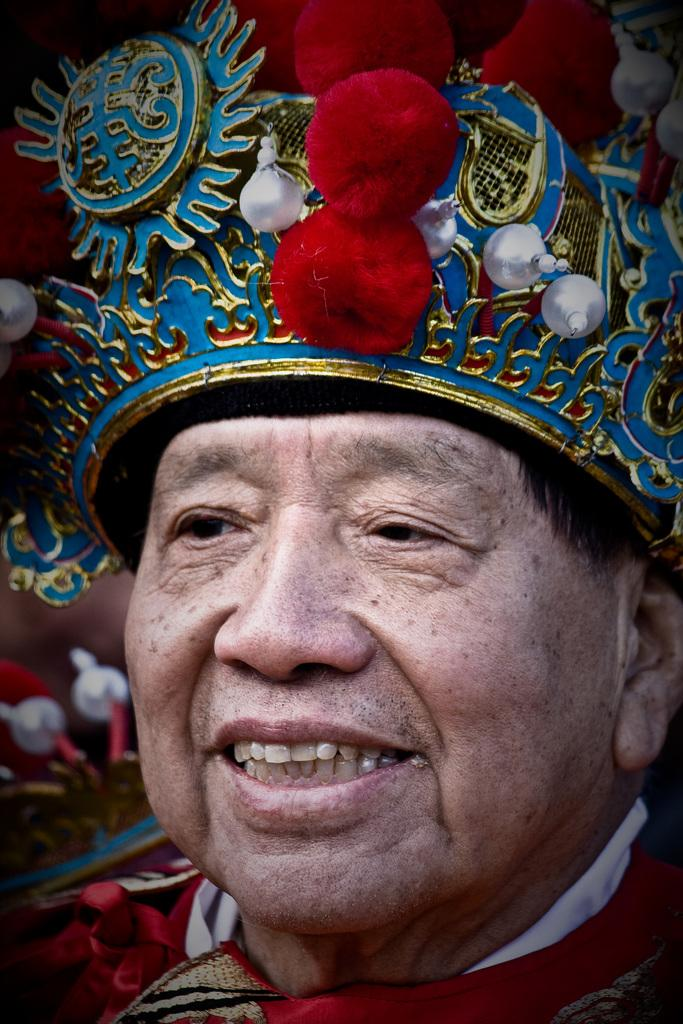Who is present in the picture? There is a man in the picture. What is the man wearing on his head? The man is wearing a cap. What expression does the man have on his face? The man has a smile on his face. Are there any other people in the picture besides the man? Yes, there are people on the side of the man. How many jellyfish can be seen swimming near the man in the picture? There are no jellyfish present in the picture; it features a man wearing a cap and smiling. What type of sheep is standing next to the man in the picture? There are no sheep present in the picture; it only features the man and other people. 